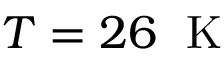Convert formula to latex. <formula><loc_0><loc_0><loc_500><loc_500>T = 2 6 \, K</formula> 